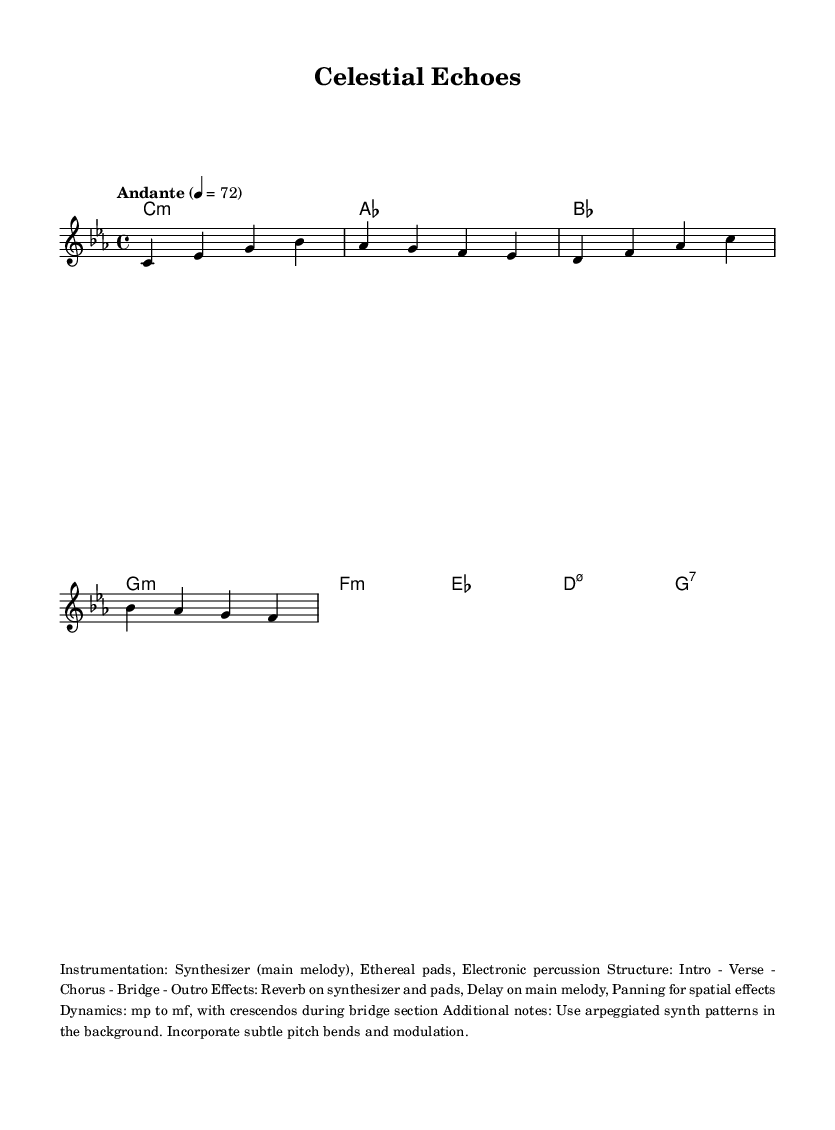What is the key signature of this music? The key signature indicates the key of the piece. In this case, it is C minor, which has three flats (B flat, E flat, and A flat). This is identified by the key signature notation at the beginning of the staff.
Answer: C minor What is the time signature of this music? The time signature defines how many beats are in each measure. Here, the time signature is 4/4, which means there are four beats in each measure. This can be observed in the time signature notation at the beginning of the staff.
Answer: 4/4 What is the tempo marking for the piece? The tempo marking indicates the speed of the music. In this piece, it is marked as Andante, which suggests a moderate walking pace. This is noted at the top of the score indicated by the text "Andante."
Answer: Andante How many measures are in the melody section? By counting the individual segments marked by bar lines in the melody, we find that there are eight measures. This is determined by visually assessing the number of measures in the melody line provided in the staff.
Answer: Eight What is the predominant instrumentation used in the piece? The instrumentation is detailed in the markup section, specifying that the main instrument is a synthesizer. This is summarized in the descriptive text that appears below the music.
Answer: Synthesizer What is the dynamic range indicated in the score? The dynamic range specifies how loud or soft the music should be played. Here, it indicates from mezzo-piano (mp) to mezzo-forte (mf), meaning the music starts moderately soft and builds up to moderately loud. This information can be found in the dynamic markings in the score.
Answer: mp to mf What type of music structure is utilized in the piece? The structure of the music is outlined in the markup section, which describes the arrangement of sections as Intro - Verse - Chorus - Bridge - Outro. This gives a clear view of the format used in the composition.
Answer: Intro - Verse - Chorus - Bridge - Outro 